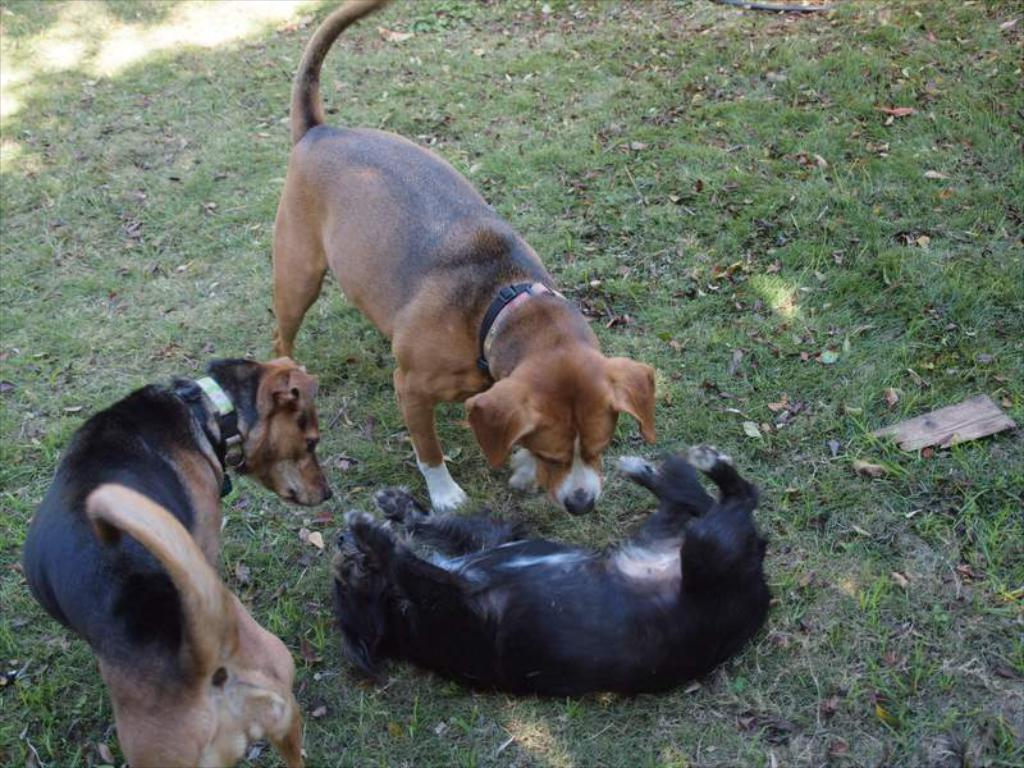How many dogs are present in the image? There are three dogs in the picture. What is the position of one of the dogs in the image? One of the dogs is lying on the ground. What are the dogs wearing around their necks? The dogs are wearing neck belts. What type of surface can be seen in the image? There is grass visible in the picture. Can you see any icicles hanging from the dogs' neck belts in the image? No, there are no icicles visible in the image. Is there a crib present in the image? No, there is no crib present in the image. 